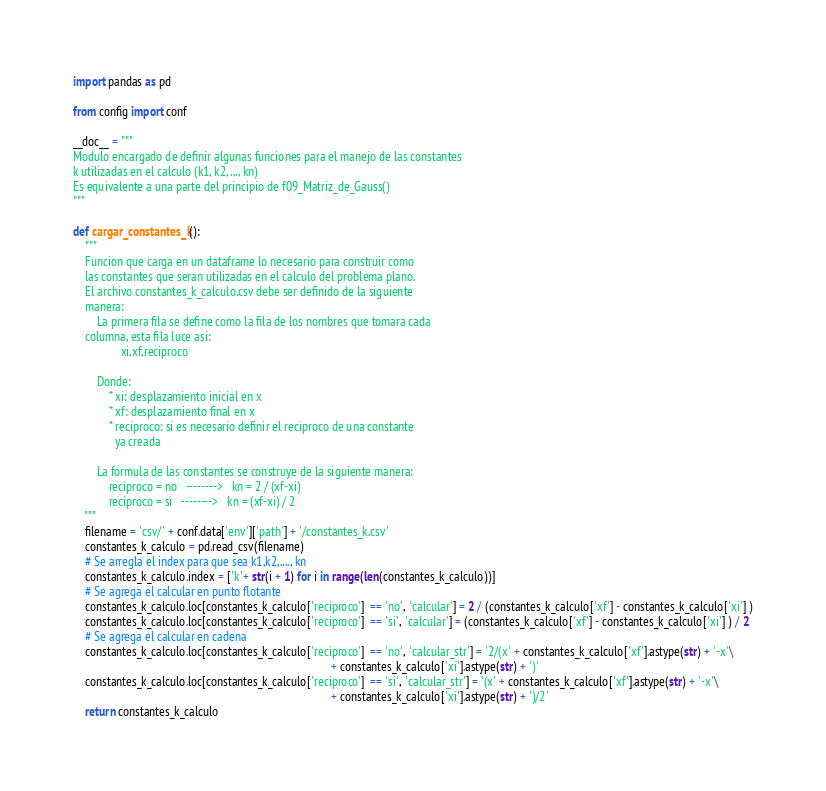Convert code to text. <code><loc_0><loc_0><loc_500><loc_500><_Python_>import pandas as pd

from config import conf

__doc__ = """
Modulo encargado de definir algunas funciones para el manejo de las constantes
k utilizadas en el calculo (k1, k2, ..., kn)
Es equivalente a una parte del principio de f09_Matriz_de_Gauss()
"""

def cargar_constantes_k():
    """
    Funcion que carga en un dataframe lo necesario para construir como
    las constantes que seran utilizadas en el calculo del problema plano.
    El archivo constantes_k_calculo.csv debe ser definido de la siguiente
    manera:
        La primera fila se define como la fila de los nombres que tomara cada
    columna, esta fila luce asi:
                xi,xf,reciproco

        Donde:
            * xi: desplazamiento inicial en x
            * xf: desplazamiento final en x
            * reciproco: si es necesario definir el reciproco de una constante
              ya creada

        La formula de las constantes se construye de la siguiente manera:
            reciproco = no   -------->   kn = 2 / (xf-xi)
            reciproco = si   -------->   kn = (xf-xi) / 2
    """
    filename = 'csv/' + conf.data['env']['path'] + '/constantes_k.csv'
    constantes_k_calculo = pd.read_csv(filename)
    # Se arregla el index para que sea k1,k2,...., kn
    constantes_k_calculo.index = ['k'+ str(i + 1) for i in range(len(constantes_k_calculo))]
    # Se agrega el calcular en punto flotante
    constantes_k_calculo.loc[constantes_k_calculo['reciproco']  == 'no', 'calcular'] = 2 / (constantes_k_calculo['xf'] - constantes_k_calculo['xi'] )
    constantes_k_calculo.loc[constantes_k_calculo['reciproco']  == 'si', 'calcular'] = (constantes_k_calculo['xf'] - constantes_k_calculo['xi'] ) / 2
    # Se agrega el calcular en cadena
    constantes_k_calculo.loc[constantes_k_calculo['reciproco']  == 'no', 'calcular_str'] = '2/(x' + constantes_k_calculo['xf'].astype(str) + '-x'\
                                                                                       + constantes_k_calculo['xi'].astype(str) + ')'
    constantes_k_calculo.loc[constantes_k_calculo['reciproco']  == 'si', 'calcular_str'] = '(x' + constantes_k_calculo['xf'].astype(str) + '-x'\
                                                                                       + constantes_k_calculo['xi'].astype(str) + ')/2'
    return constantes_k_calculo
</code> 